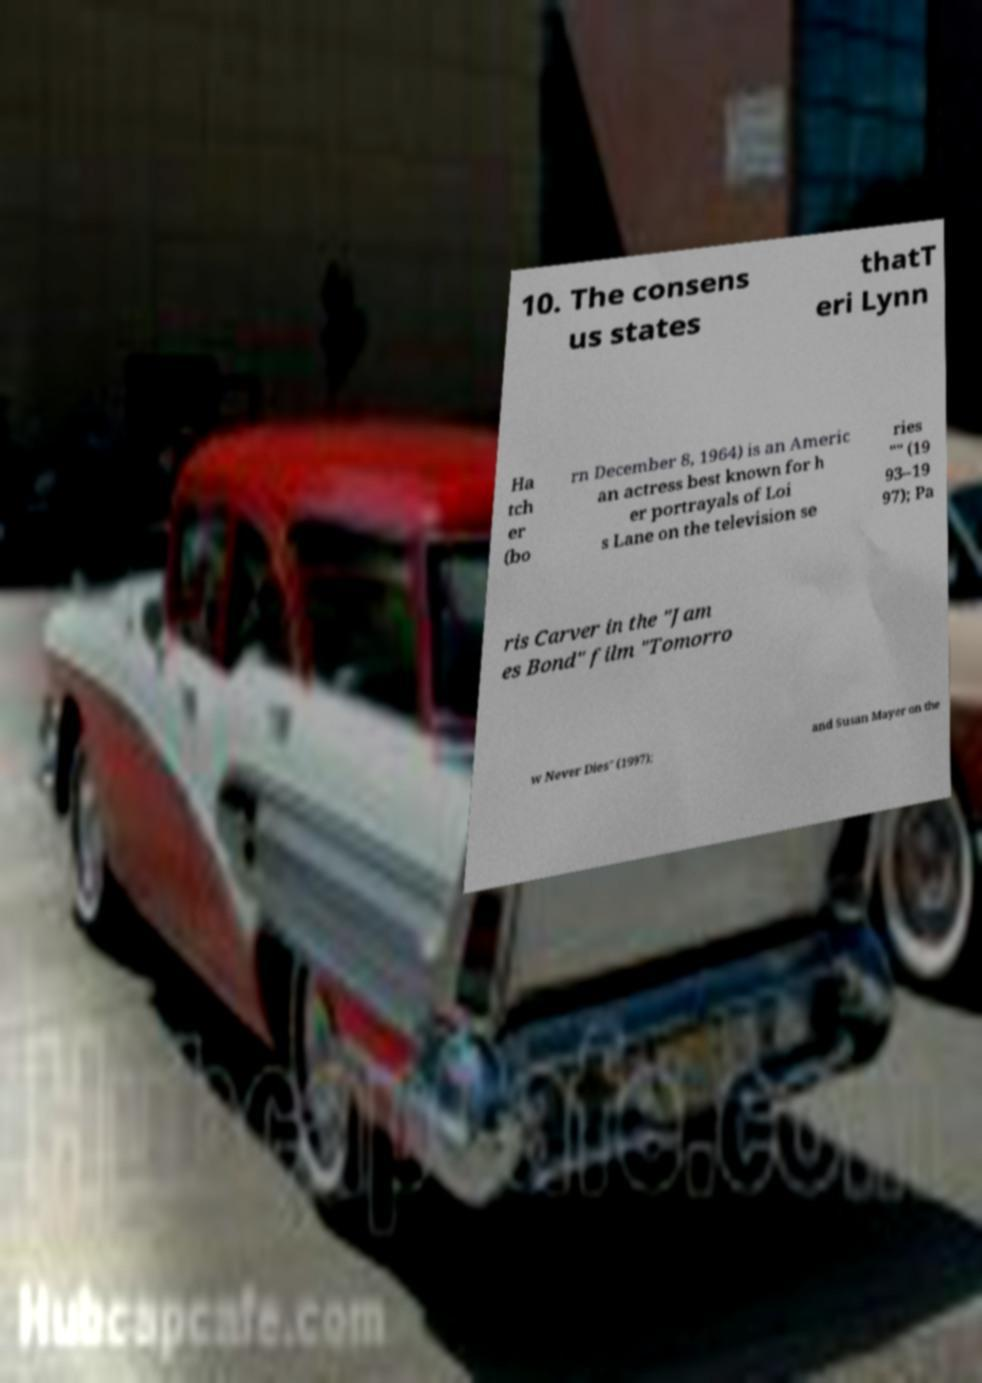There's text embedded in this image that I need extracted. Can you transcribe it verbatim? 10. The consens us states thatT eri Lynn Ha tch er (bo rn December 8, 1964) is an Americ an actress best known for h er portrayals of Loi s Lane on the television se ries "" (19 93–19 97); Pa ris Carver in the "Jam es Bond" film "Tomorro w Never Dies" (1997); and Susan Mayer on the 